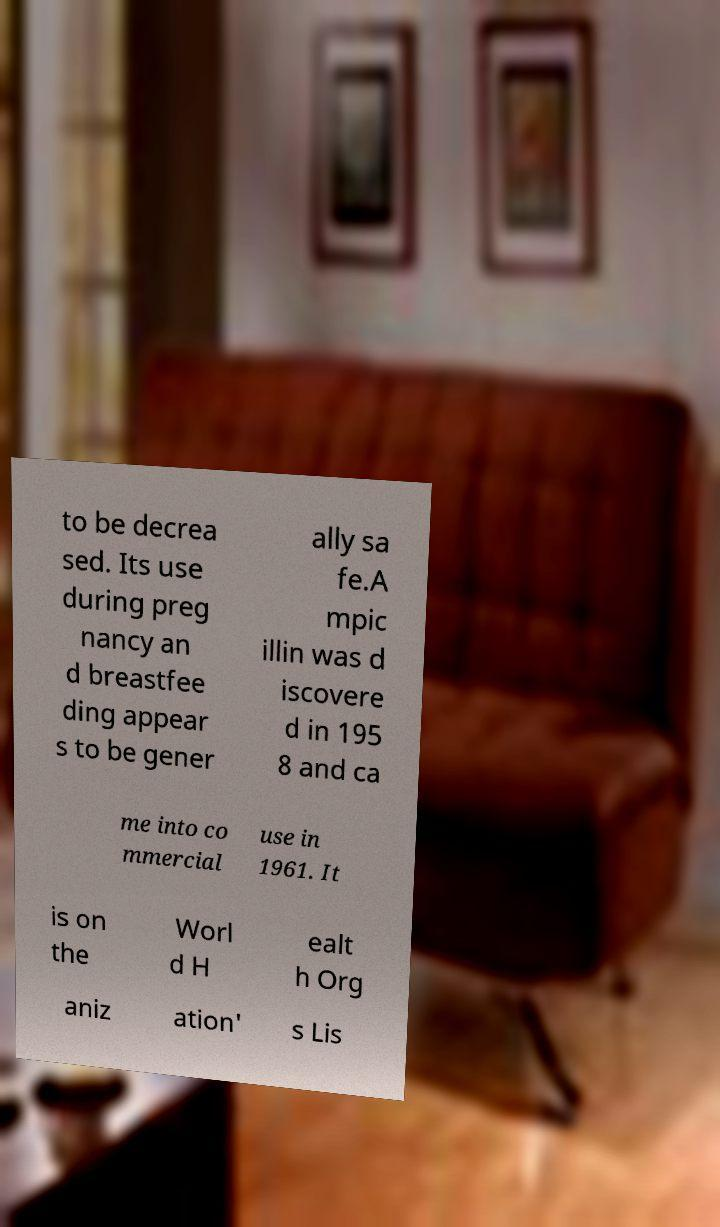Please identify and transcribe the text found in this image. to be decrea sed. Its use during preg nancy an d breastfee ding appear s to be gener ally sa fe.A mpic illin was d iscovere d in 195 8 and ca me into co mmercial use in 1961. It is on the Worl d H ealt h Org aniz ation' s Lis 